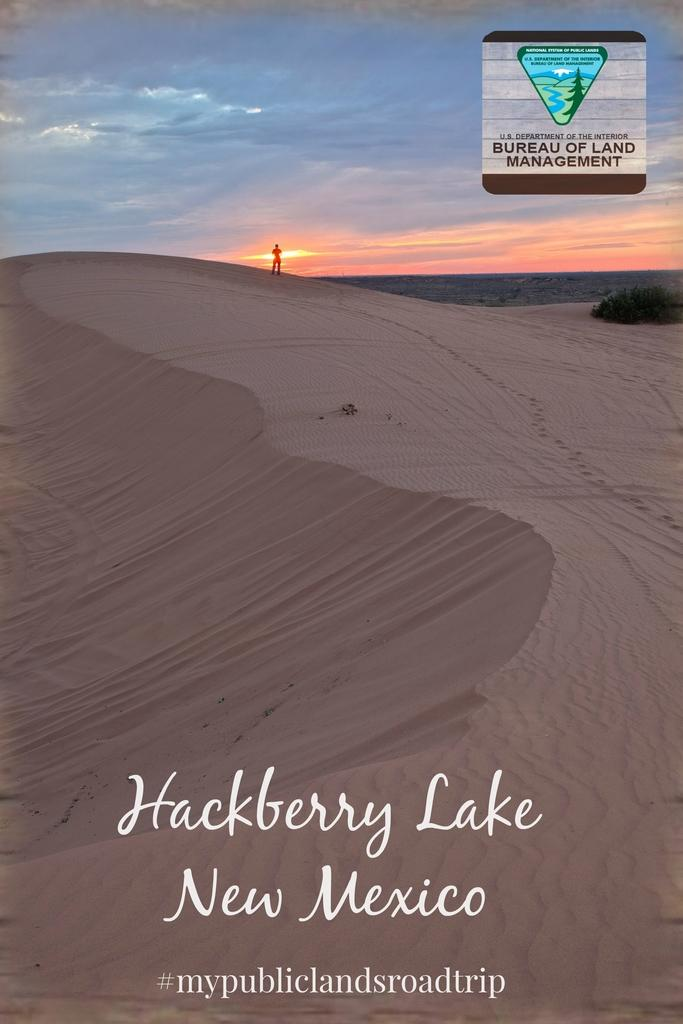<image>
Offer a succinct explanation of the picture presented. The image on a travel poster is from the sand dunes of Hackberry Lake in New Mexico. 